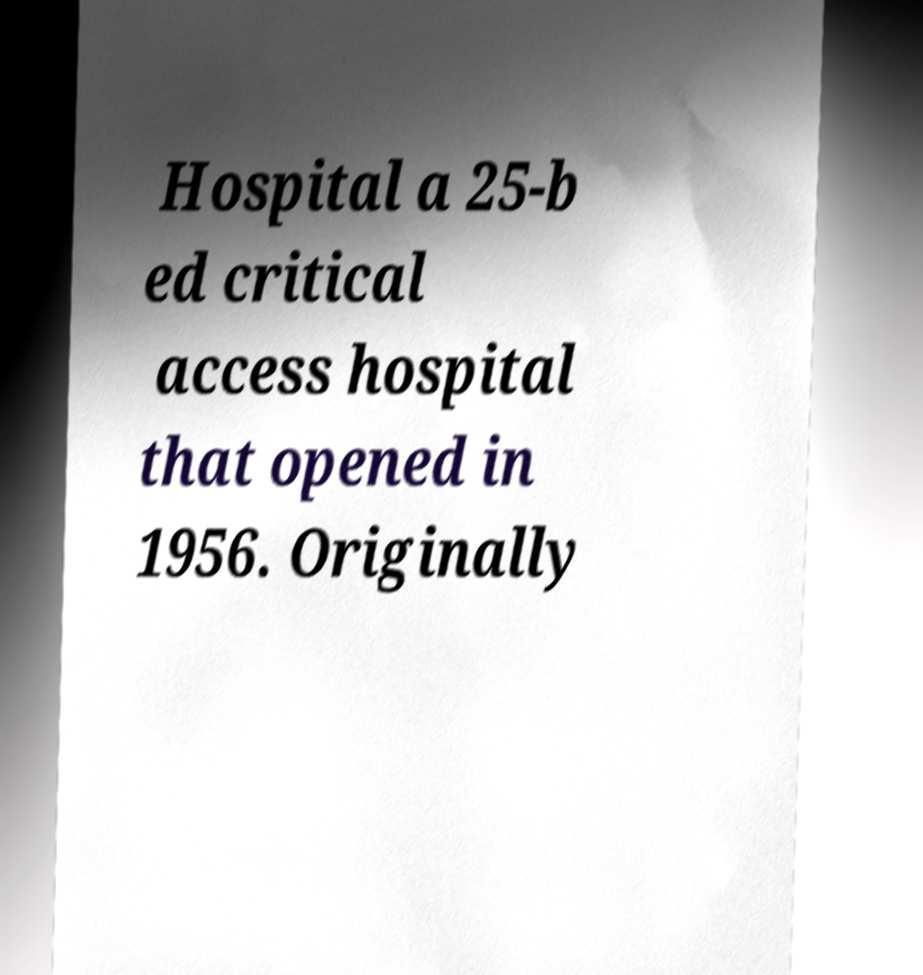Could you extract and type out the text from this image? Hospital a 25-b ed critical access hospital that opened in 1956. Originally 